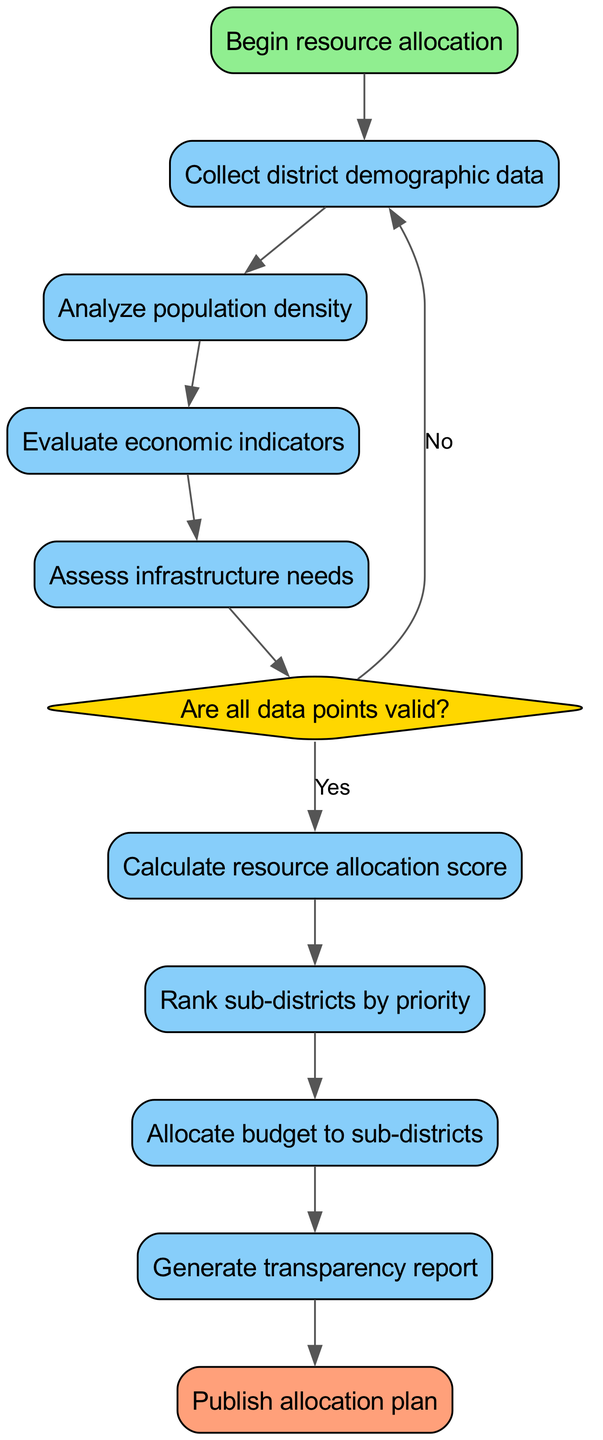What is the first step in the resource allocation process? The first step, according to the diagram, is "Begin resource allocation."
Answer: Begin resource allocation How many total process nodes are there in the diagram? There are five process nodes, which are: "Collect district demographic data," "Analyze population density," "Evaluate economic indicators," "Assess infrastructure needs," and "Calculate resource allocation score."
Answer: Five What happens if the data points are not valid? If the data points are not valid, the flowchart indicates that it returns to "Collect district demographic data."
Answer: Collect district demographic data What is the last step in the algorithm? The last step in the algorithm is "Publish allocation plan."
Answer: Publish allocation plan What is assessed after evaluating economic indicators? After evaluating economic indicators, the next step is to "Assess infrastructure needs."
Answer: Assess infrastructure needs What shape is used for decision nodes in this flowchart? Decision nodes in this flowchart are represented by a diamond shape.
Answer: Diamond What is generated after allocating the budget to sub-districts? The diagram indicates that after allocating the budget to sub-districts, a "Generate transparency report" step follows.
Answer: Generate transparency report How many connections lead out from the "Are all data points valid?" node? There are two connections that lead out from the "Are all data points valid?" node: one to "Calculate resource allocation score" if yes, and one back to "Collect district demographic data" if no.
Answer: Two What type of data is collected in the second step? The second step involves collecting "district demographic data."
Answer: District demographic data 